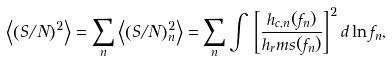Convert formula to latex. <formula><loc_0><loc_0><loc_500><loc_500>\left \langle \left ( S / N \right ) ^ { 2 } \right \rangle = \sum _ { n } \left \langle \left ( S / N \right ) _ { n } ^ { 2 } \right \rangle = \sum _ { n } \int \, \left [ \frac { h _ { c , n } ( f _ { n } ) } { h _ { r } m s ( f _ { n } ) } \right ] ^ { 2 } d \ln f _ { n } ,</formula> 